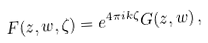<formula> <loc_0><loc_0><loc_500><loc_500>F ( z , w , \zeta ) = e ^ { 4 \pi i k \zeta } G ( z , w ) \, ,</formula> 